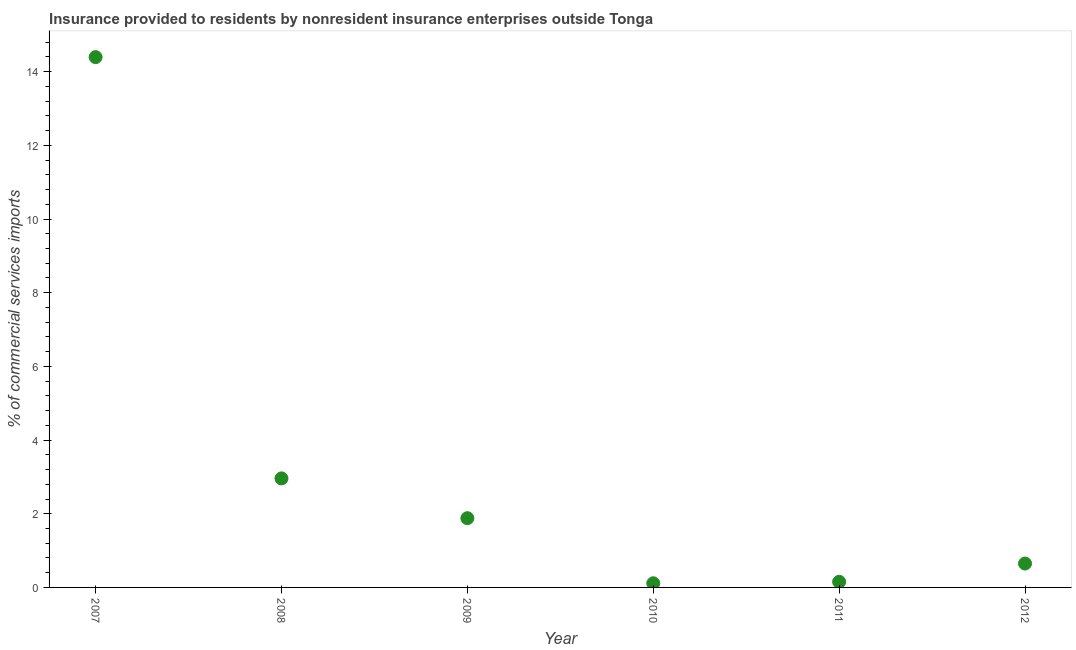What is the insurance provided by non-residents in 2008?
Your answer should be very brief. 2.96. Across all years, what is the maximum insurance provided by non-residents?
Your answer should be very brief. 14.4. Across all years, what is the minimum insurance provided by non-residents?
Keep it short and to the point. 0.11. What is the sum of the insurance provided by non-residents?
Provide a succinct answer. 20.15. What is the difference between the insurance provided by non-residents in 2009 and 2010?
Give a very brief answer. 1.77. What is the average insurance provided by non-residents per year?
Give a very brief answer. 3.36. What is the median insurance provided by non-residents?
Ensure brevity in your answer.  1.26. In how many years, is the insurance provided by non-residents greater than 13.6 %?
Offer a very short reply. 1. What is the ratio of the insurance provided by non-residents in 2008 to that in 2010?
Your answer should be very brief. 26.28. Is the difference between the insurance provided by non-residents in 2008 and 2010 greater than the difference between any two years?
Offer a terse response. No. What is the difference between the highest and the second highest insurance provided by non-residents?
Offer a very short reply. 11.43. What is the difference between the highest and the lowest insurance provided by non-residents?
Give a very brief answer. 14.28. Does the insurance provided by non-residents monotonically increase over the years?
Your answer should be compact. No. What is the difference between two consecutive major ticks on the Y-axis?
Offer a terse response. 2. Does the graph contain any zero values?
Keep it short and to the point. No. Does the graph contain grids?
Your answer should be very brief. No. What is the title of the graph?
Give a very brief answer. Insurance provided to residents by nonresident insurance enterprises outside Tonga. What is the label or title of the X-axis?
Provide a short and direct response. Year. What is the label or title of the Y-axis?
Your answer should be very brief. % of commercial services imports. What is the % of commercial services imports in 2007?
Provide a short and direct response. 14.4. What is the % of commercial services imports in 2008?
Provide a short and direct response. 2.96. What is the % of commercial services imports in 2009?
Give a very brief answer. 1.88. What is the % of commercial services imports in 2010?
Keep it short and to the point. 0.11. What is the % of commercial services imports in 2011?
Offer a very short reply. 0.15. What is the % of commercial services imports in 2012?
Ensure brevity in your answer.  0.65. What is the difference between the % of commercial services imports in 2007 and 2008?
Give a very brief answer. 11.43. What is the difference between the % of commercial services imports in 2007 and 2009?
Make the answer very short. 12.52. What is the difference between the % of commercial services imports in 2007 and 2010?
Your answer should be compact. 14.28. What is the difference between the % of commercial services imports in 2007 and 2011?
Offer a terse response. 14.24. What is the difference between the % of commercial services imports in 2007 and 2012?
Make the answer very short. 13.75. What is the difference between the % of commercial services imports in 2008 and 2009?
Give a very brief answer. 1.08. What is the difference between the % of commercial services imports in 2008 and 2010?
Give a very brief answer. 2.85. What is the difference between the % of commercial services imports in 2008 and 2011?
Make the answer very short. 2.81. What is the difference between the % of commercial services imports in 2008 and 2012?
Your answer should be compact. 2.31. What is the difference between the % of commercial services imports in 2009 and 2010?
Your answer should be compact. 1.77. What is the difference between the % of commercial services imports in 2009 and 2011?
Your answer should be very brief. 1.73. What is the difference between the % of commercial services imports in 2009 and 2012?
Provide a short and direct response. 1.23. What is the difference between the % of commercial services imports in 2010 and 2011?
Provide a short and direct response. -0.04. What is the difference between the % of commercial services imports in 2010 and 2012?
Ensure brevity in your answer.  -0.54. What is the difference between the % of commercial services imports in 2011 and 2012?
Keep it short and to the point. -0.5. What is the ratio of the % of commercial services imports in 2007 to that in 2008?
Provide a short and direct response. 4.86. What is the ratio of the % of commercial services imports in 2007 to that in 2009?
Your answer should be very brief. 7.66. What is the ratio of the % of commercial services imports in 2007 to that in 2010?
Your answer should be very brief. 127.8. What is the ratio of the % of commercial services imports in 2007 to that in 2011?
Provide a short and direct response. 94.18. What is the ratio of the % of commercial services imports in 2007 to that in 2012?
Give a very brief answer. 22.2. What is the ratio of the % of commercial services imports in 2008 to that in 2009?
Give a very brief answer. 1.57. What is the ratio of the % of commercial services imports in 2008 to that in 2010?
Provide a short and direct response. 26.28. What is the ratio of the % of commercial services imports in 2008 to that in 2011?
Provide a short and direct response. 19.37. What is the ratio of the % of commercial services imports in 2008 to that in 2012?
Provide a short and direct response. 4.56. What is the ratio of the % of commercial services imports in 2009 to that in 2010?
Ensure brevity in your answer.  16.69. What is the ratio of the % of commercial services imports in 2009 to that in 2011?
Ensure brevity in your answer.  12.3. What is the ratio of the % of commercial services imports in 2009 to that in 2012?
Provide a short and direct response. 2.9. What is the ratio of the % of commercial services imports in 2010 to that in 2011?
Make the answer very short. 0.74. What is the ratio of the % of commercial services imports in 2010 to that in 2012?
Give a very brief answer. 0.17. What is the ratio of the % of commercial services imports in 2011 to that in 2012?
Your response must be concise. 0.24. 